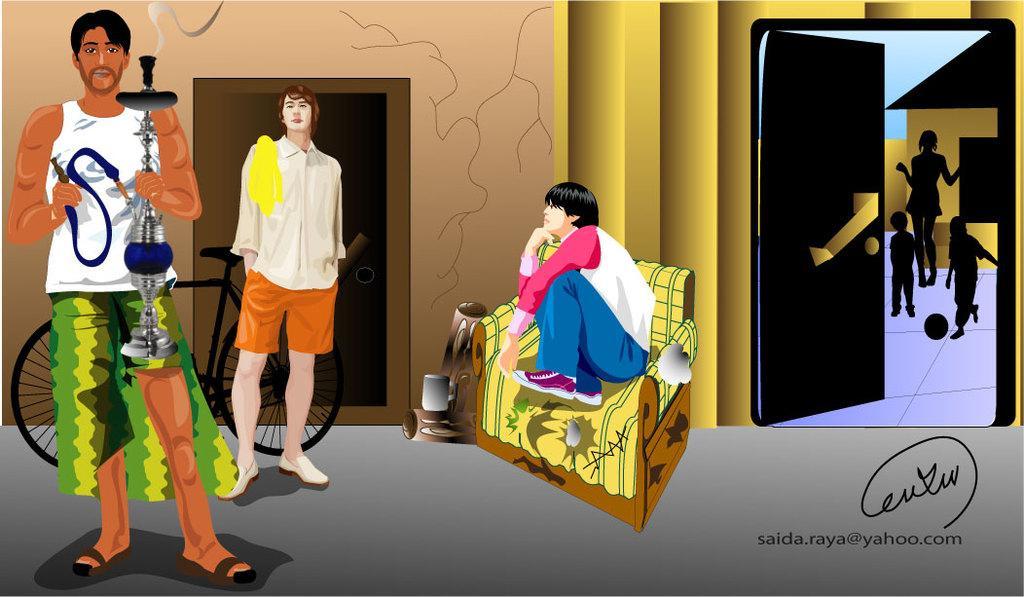Could you give a brief overview of what you see in this image? In the picture we can see a painting on it we can see a man standing with hukka pot and behind him we can see another person standing near the bicycle and in the background we can see a wall with two doors and one door is opened. 